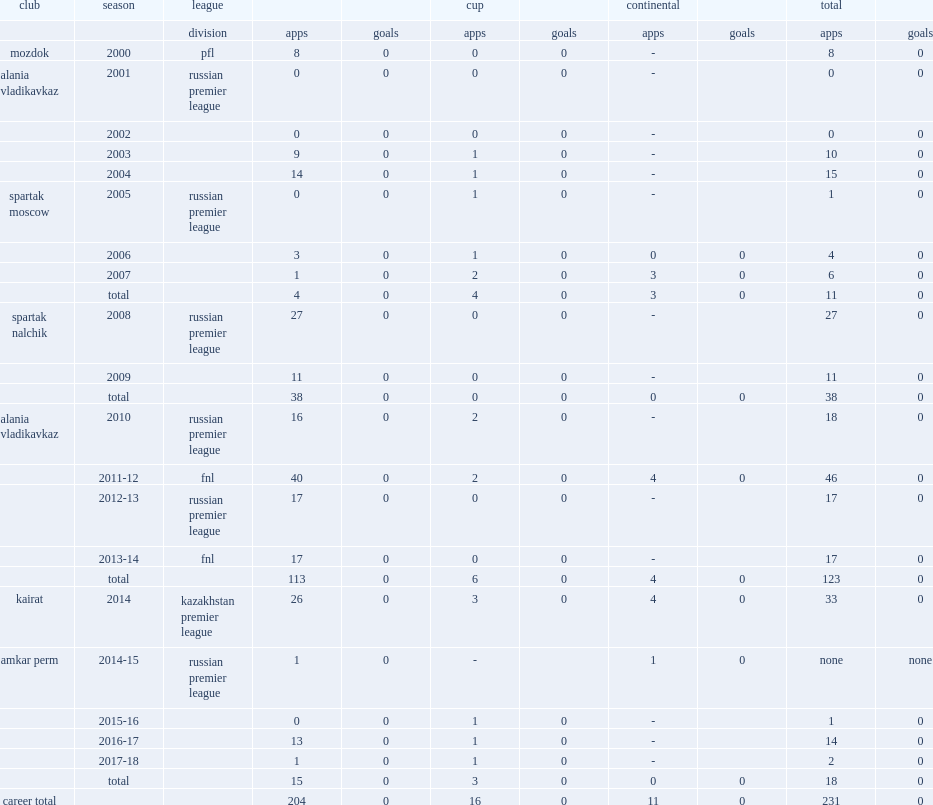Which club did khomich play for in 2014? Kairat. 